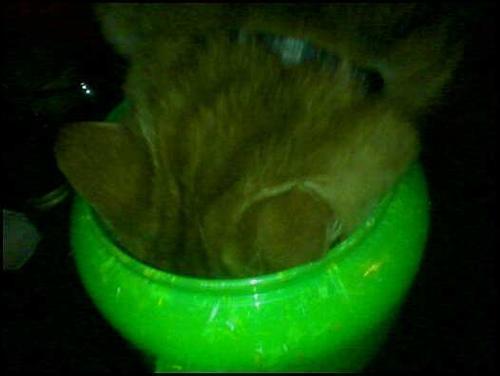How many cats are visible?
Give a very brief answer. 1. 